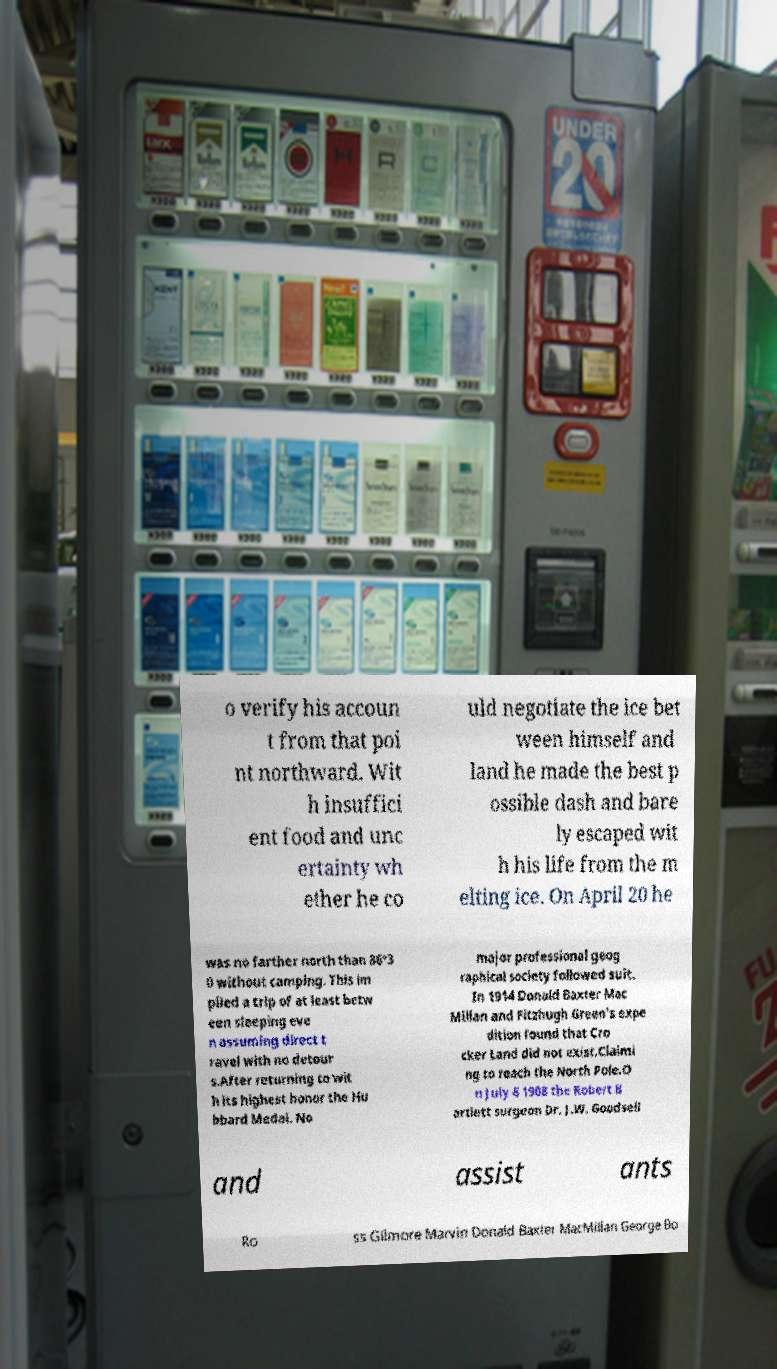Please identify and transcribe the text found in this image. o verify his accoun t from that poi nt northward. Wit h insuffici ent food and unc ertainty wh ether he co uld negotiate the ice bet ween himself and land he made the best p ossible dash and bare ly escaped wit h his life from the m elting ice. On April 20 he was no farther north than 86°3 0 without camping. This im plied a trip of at least betw een sleeping eve n assuming direct t ravel with no detour s.After returning to wit h its highest honor the Hu bbard Medal. No major professional geog raphical society followed suit. In 1914 Donald Baxter Mac Millan and Fitzhugh Green's expe dition found that Cro cker Land did not exist.Claimi ng to reach the North Pole.O n July 6 1908 the Robert B artlett surgeon Dr. J.W. Goodsell and assist ants Ro ss Gilmore Marvin Donald Baxter MacMillan George Bo 